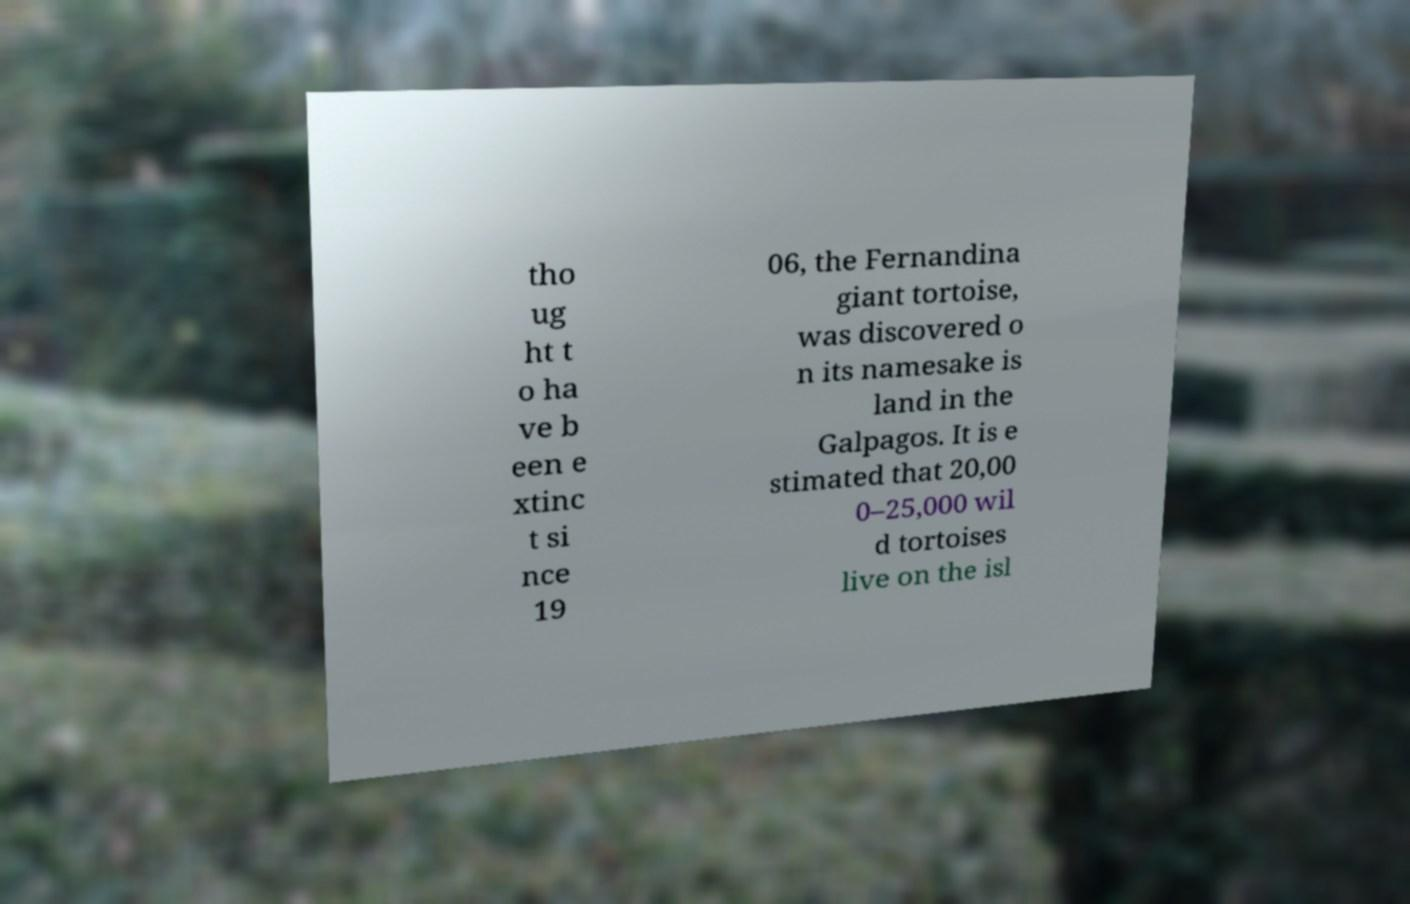For documentation purposes, I need the text within this image transcribed. Could you provide that? tho ug ht t o ha ve b een e xtinc t si nce 19 06, the Fernandina giant tortoise, was discovered o n its namesake is land in the Galpagos. It is e stimated that 20,00 0–25,000 wil d tortoises live on the isl 